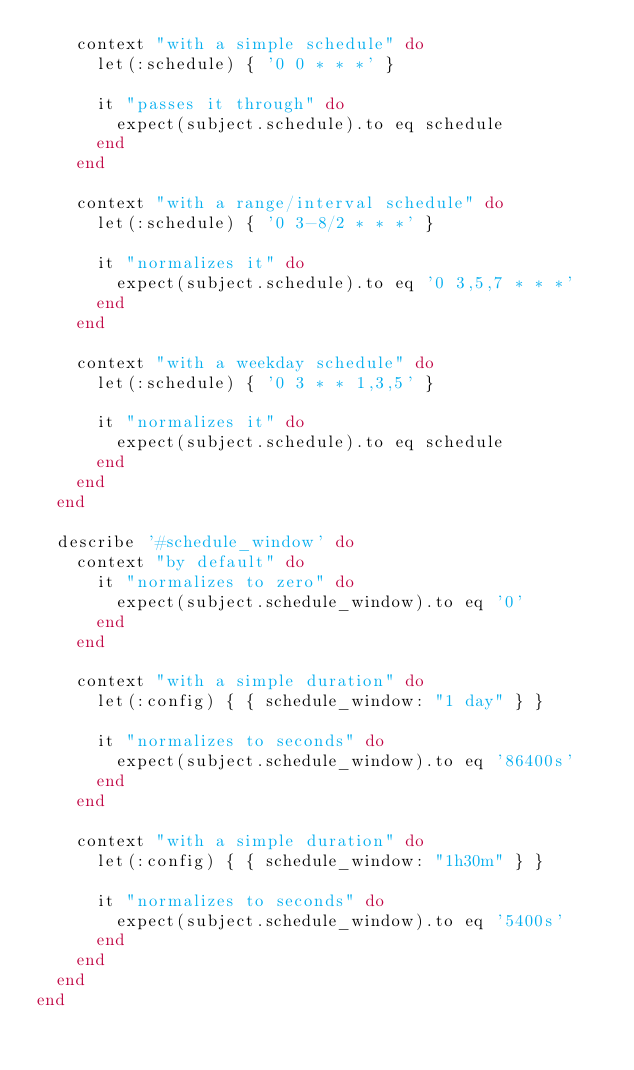Convert code to text. <code><loc_0><loc_0><loc_500><loc_500><_Ruby_>    context "with a simple schedule" do
      let(:schedule) { '0 0 * * *' }

      it "passes it through" do
        expect(subject.schedule).to eq schedule
      end
    end

    context "with a range/interval schedule" do
      let(:schedule) { '0 3-8/2 * * *' }

      it "normalizes it" do
        expect(subject.schedule).to eq '0 3,5,7 * * *'
      end
    end

    context "with a weekday schedule" do
      let(:schedule) { '0 3 * * 1,3,5' }

      it "normalizes it" do
        expect(subject.schedule).to eq schedule
      end
    end
  end

  describe '#schedule_window' do
    context "by default" do
      it "normalizes to zero" do
        expect(subject.schedule_window).to eq '0'
      end
    end

    context "with a simple duration" do
      let(:config) { { schedule_window: "1 day" } }

      it "normalizes to seconds" do
        expect(subject.schedule_window).to eq '86400s'
      end
    end

    context "with a simple duration" do
      let(:config) { { schedule_window: "1h30m" } }

      it "normalizes to seconds" do
        expect(subject.schedule_window).to eq '5400s'
      end
    end
  end
end
</code> 